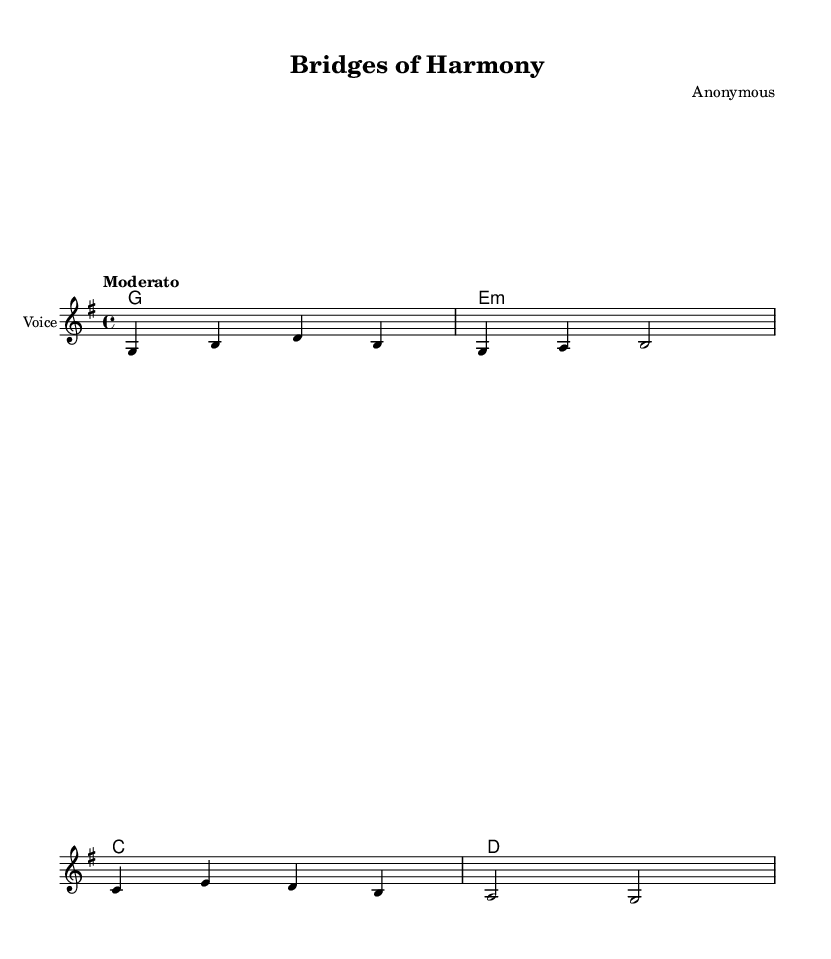What is the key signature of this music? The key signature can be determined by looking at the sharp or flat symbols present at the beginning of the staff. In this case, the absence of such symbols indicates that the key is G major, which has one sharp.
Answer: G major What is the time signature of this music? The time signature is indicated at the beginning of the staff, where the two numbers are shown. Here, the time signature is 4/4, which means there are four beats in each measure and the quarter note gets one beat.
Answer: 4/4 What is the tempo marking for this piece? The tempo marking is found above the staff and is written in Italian. In this score, it states "Moderato," which indicates a moderate tempo.
Answer: Moderato How many measures are displayed in the sheet music? By counting the number of vertical lines that separate the musical phrases, we see there are four measures in this excerpt. Each measure is visually divided by bar lines.
Answer: Four Who is the composer of the piece? The composer's name is listed in the header section of the score. In this case, it is indicated as "Anonymous," showing that the composer is unknown.
Answer: Anonymous What type of song is "Bridges of Harmony"? The title of the piece and its lyrical content suggest it promotes cultural understanding and unity through its message. This type of song is often categorized as a folk song.
Answer: Folk song Which instrument is specified for the melody? The instrument name is written in the staff configuration. Here, it states "Voice," indicating that the melody is intended for a vocalist.
Answer: Voice 